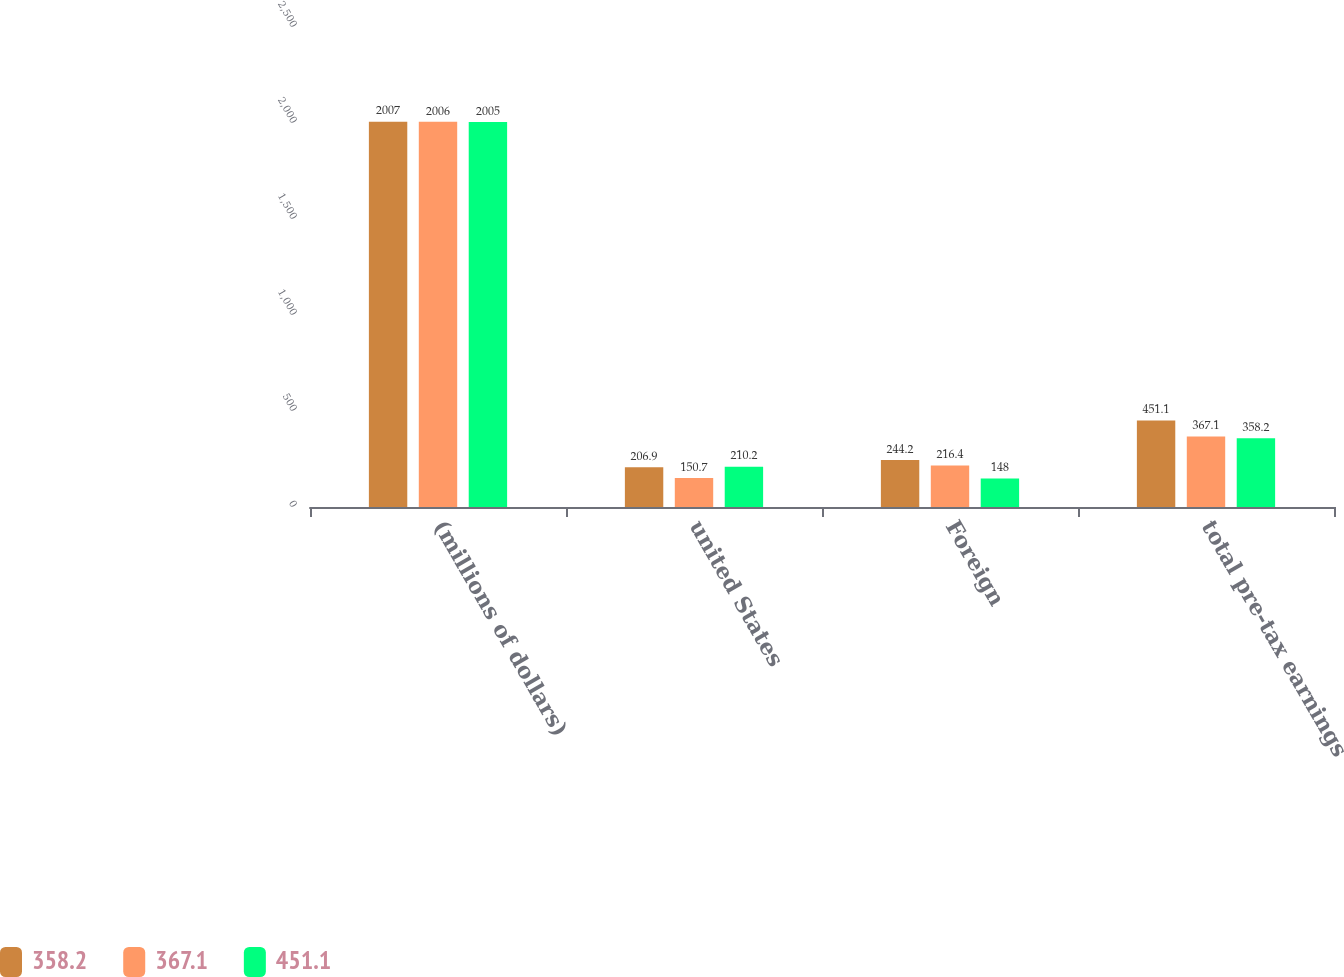Convert chart. <chart><loc_0><loc_0><loc_500><loc_500><stacked_bar_chart><ecel><fcel>(millions of dollars)<fcel>united States<fcel>Foreign<fcel>total pre-tax earnings<nl><fcel>358.2<fcel>2007<fcel>206.9<fcel>244.2<fcel>451.1<nl><fcel>367.1<fcel>2006<fcel>150.7<fcel>216.4<fcel>367.1<nl><fcel>451.1<fcel>2005<fcel>210.2<fcel>148<fcel>358.2<nl></chart> 